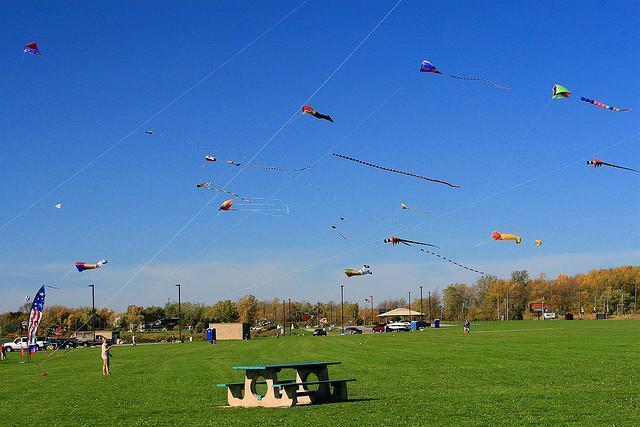How many books are in the volume?
Give a very brief answer. 0. 